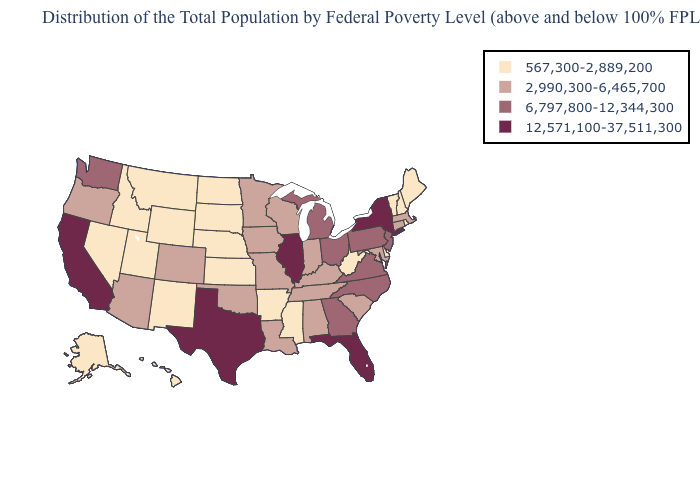Which states have the highest value in the USA?
Keep it brief. California, Florida, Illinois, New York, Texas. What is the lowest value in states that border Ohio?
Write a very short answer. 567,300-2,889,200. What is the value of Illinois?
Write a very short answer. 12,571,100-37,511,300. Which states have the highest value in the USA?
Answer briefly. California, Florida, Illinois, New York, Texas. Does New York have the highest value in the USA?
Be succinct. Yes. Does the first symbol in the legend represent the smallest category?
Short answer required. Yes. Among the states that border West Virginia , does Kentucky have the highest value?
Write a very short answer. No. Which states have the highest value in the USA?
Be succinct. California, Florida, Illinois, New York, Texas. Does Iowa have a lower value than Nebraska?
Quick response, please. No. Does the map have missing data?
Give a very brief answer. No. Name the states that have a value in the range 567,300-2,889,200?
Keep it brief. Alaska, Arkansas, Delaware, Hawaii, Idaho, Kansas, Maine, Mississippi, Montana, Nebraska, Nevada, New Hampshire, New Mexico, North Dakota, Rhode Island, South Dakota, Utah, Vermont, West Virginia, Wyoming. What is the lowest value in the USA?
Be succinct. 567,300-2,889,200. Does Indiana have the same value as Alabama?
Short answer required. Yes. What is the value of New York?
Write a very short answer. 12,571,100-37,511,300. What is the value of Louisiana?
Concise answer only. 2,990,300-6,465,700. 